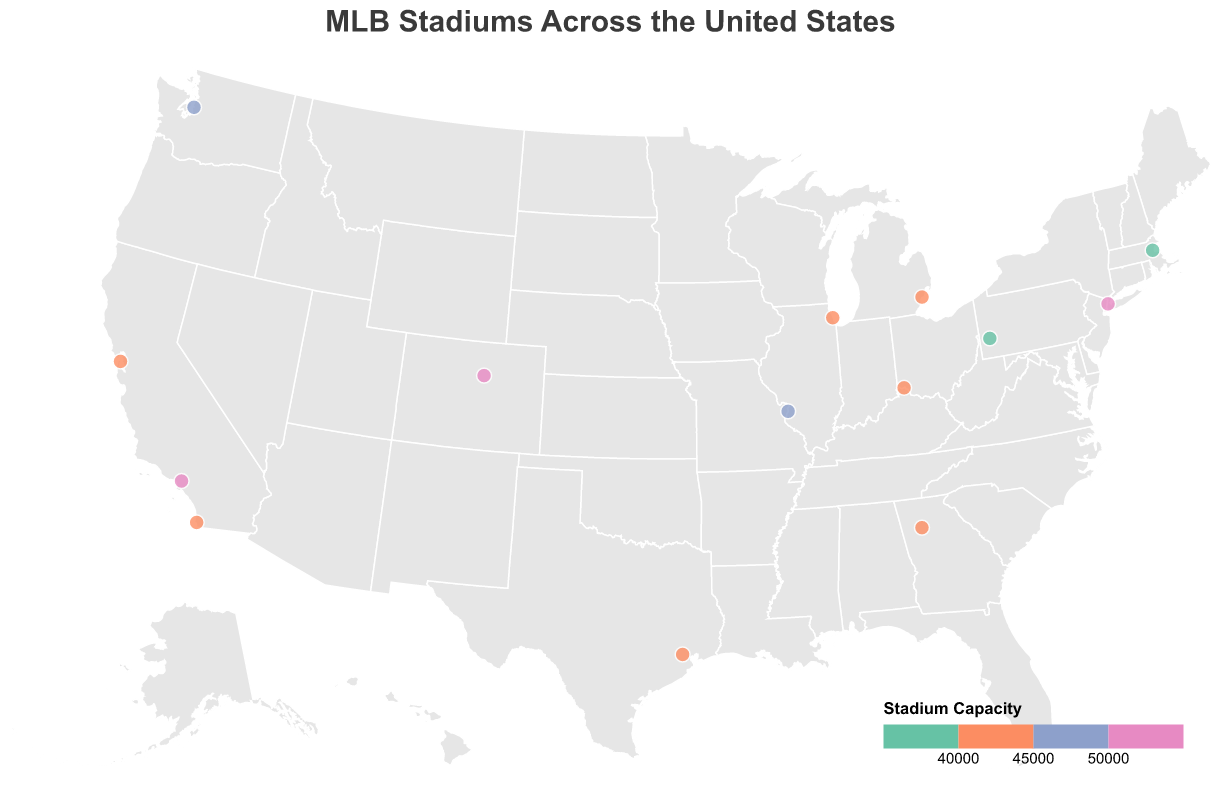Which stadium has the highest seating capacity? Based on the color legend in the figure, the darkest color represents the highest capacity. Dodger Stadium in Los Angeles, California, is the darkest, indicating it has the highest capacity. The tooltip confirms this.
Answer: Dodger Stadium Which stadium has the lowest seating capacity? Based on the color legend in the figure, the lightest color represents the lowest capacity. Fenway Park in Boston, Massachusetts, is the lightest, indicating it has the lowest capacity. The tooltip confirms this.
Answer: Fenway Park How many stadiums are there in California? To determine the number of stadiums in California, we identify all the stadiums located in Californian cities from the names in the figure: Dodger Stadium, Oracle Park, and Petco Park. This confirms there are three stadiums.
Answer: 3 Which stadiums have a seating capacity above 50,000? From the figure, stadiums with colors that correspond to capacities above 50,000 are darker than those with lower capacities. Dodger Stadium and Coors Field fall into this category, confirmed by checking their tooltip capacities.
Answer: Dodger Stadium and Coors Field Compare the seating capacity of Fenway Park and T-Mobile Park. Which one is larger? Using the tooltips, we see Fenway Park has a capacity of 37,731 and T-Mobile Park has 47,929. Therefore, T-Mobile Park has a larger capacity.
Answer: T-Mobile Park What is the difference in seating capacity between Yankee Stadium and Truist Park? Consulting the tooltips, Yankee Stadium has a capacity of 54,251, and Truist Park has 41,084. Subtracting the smaller from the larger gives 54,251 - 41,084 = 13,167.
Answer: 13,167 Which stadiums are located in cities with similar latitudes? From the geographic placement of the stadium circles on the map, Fenway Park and Comerica Park are at similar latitudes around 42 degrees.
Answer: Fenway Park and Comerica Park List all the stadiums located on the West Coast of the United States. Based on the locations on the map, stadiums on the West Coast are in California and Washington: Dodger Stadium, Oracle Park, Petco Park, and T-Mobile Park.
Answer: Dodger Stadium, Oracle Park, Petco Park, T-Mobile Park Which state has the most brightly colored stadiums according to the capacity color legend? The state of California has three stadiums: Dodger Stadium, Oracle Park, and Petco Park, each colored at different levels, demonstrating varying capacities.
Answer: California 